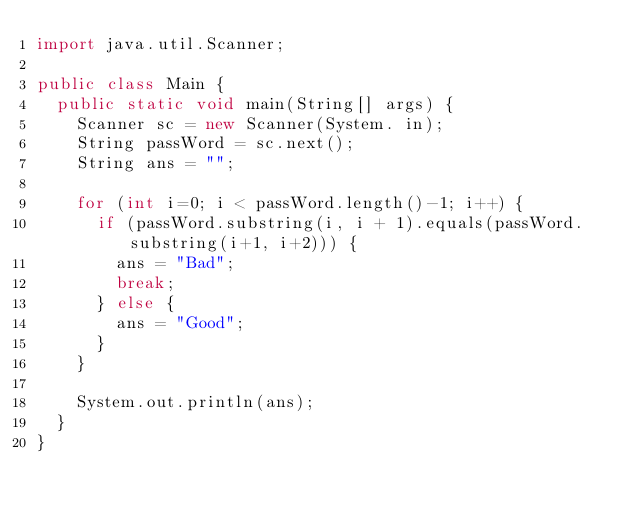Convert code to text. <code><loc_0><loc_0><loc_500><loc_500><_Java_>import java.util.Scanner;
 
public class Main {
  public static void main(String[] args) {
    Scanner sc = new Scanner(System. in);
    String passWord = sc.next();
    String ans = "";

    for (int i=0; i < passWord.length()-1; i++) {
      if (passWord.substring(i, i + 1).equals(passWord.substring(i+1, i+2))) {
        ans = "Bad";
        break;
      } else {
        ans = "Good";
      }
    }

    System.out.println(ans);
  }
}
</code> 